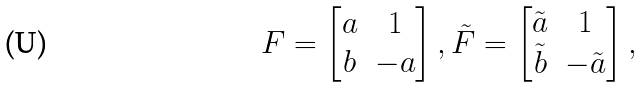Convert formula to latex. <formula><loc_0><loc_0><loc_500><loc_500>F = \begin{bmatrix} a & 1 \\ b & - a \end{bmatrix} , \tilde { F } = \begin{bmatrix} \tilde { a } & 1 \\ \tilde { b } & - \tilde { a } \end{bmatrix} ,</formula> 